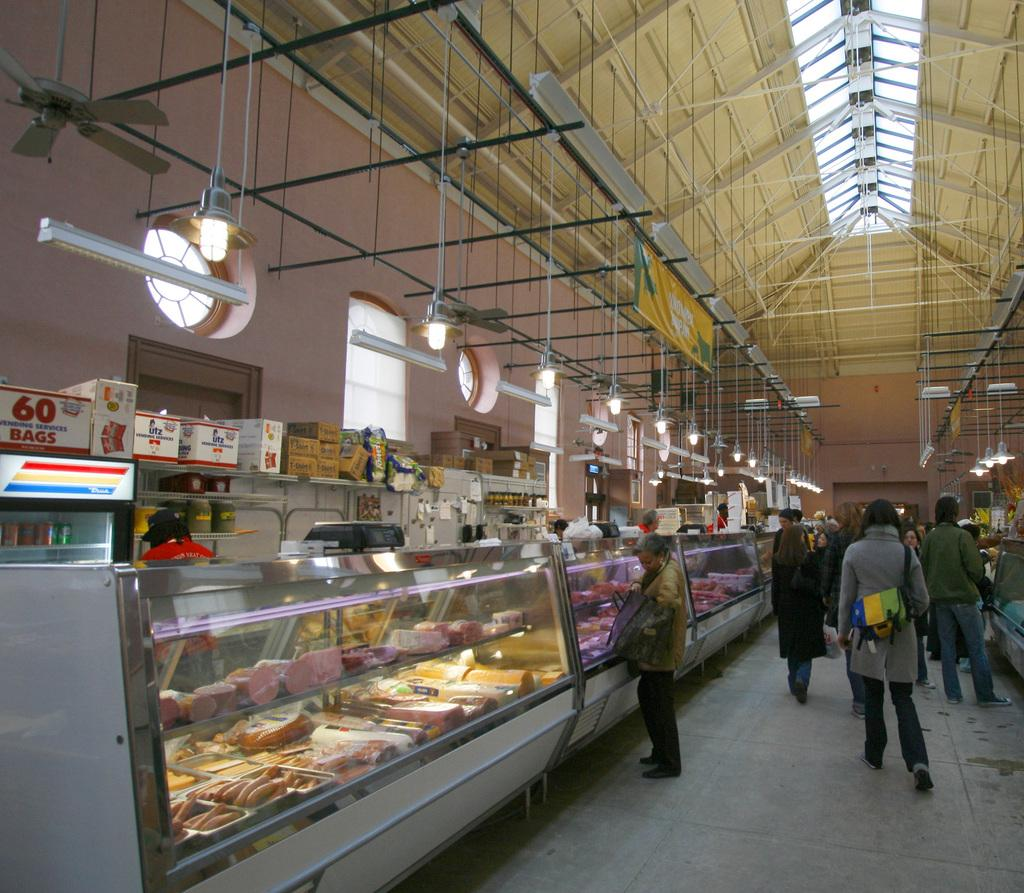<image>
Render a clear and concise summary of the photo. 60 bags box on top of a freezer in a market. 